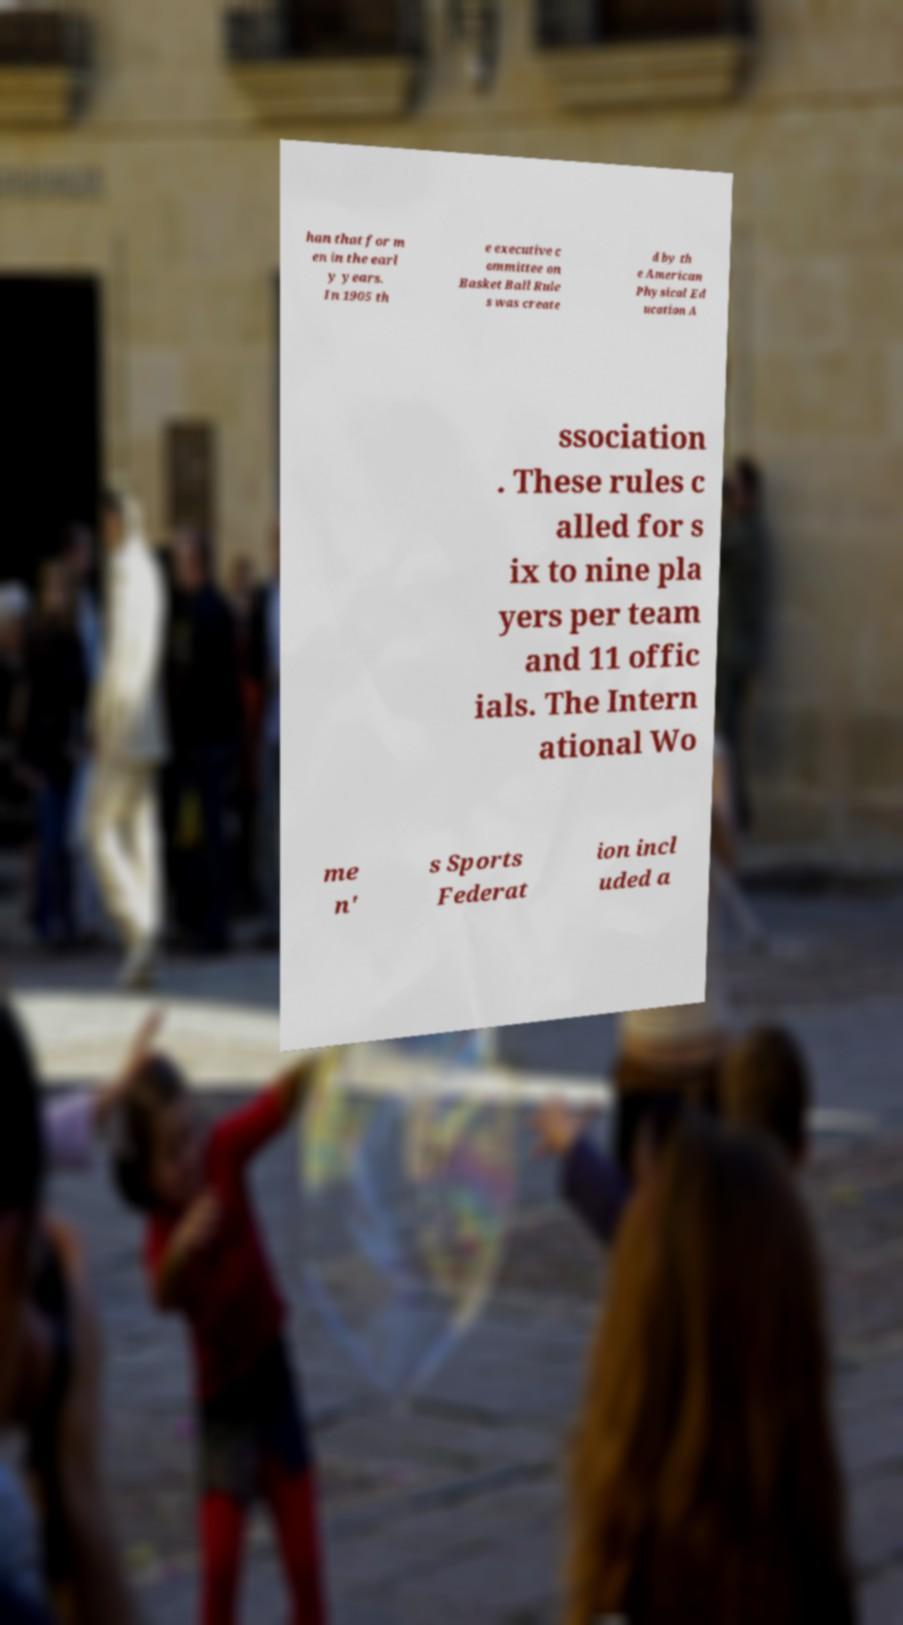Can you read and provide the text displayed in the image?This photo seems to have some interesting text. Can you extract and type it out for me? han that for m en in the earl y years. In 1905 th e executive c ommittee on Basket Ball Rule s was create d by th e American Physical Ed ucation A ssociation . These rules c alled for s ix to nine pla yers per team and 11 offic ials. The Intern ational Wo me n' s Sports Federat ion incl uded a 